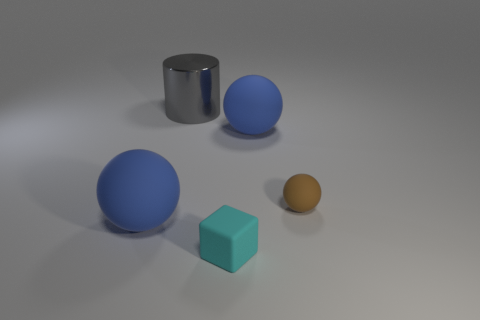What materials do the objects seem to be made of in this image? The objects in the image display a variety of textures which suggest different materials. The cyan cube appears to have a matte, solid surface, likely representing a plastic or painted wood material. The large sphere and the cylinder have a more reflective surface, indicative of metal or polished stone, while the small brown sphere appears to have a rougher, more matte finish, resembling rubber or a textured plastic. 